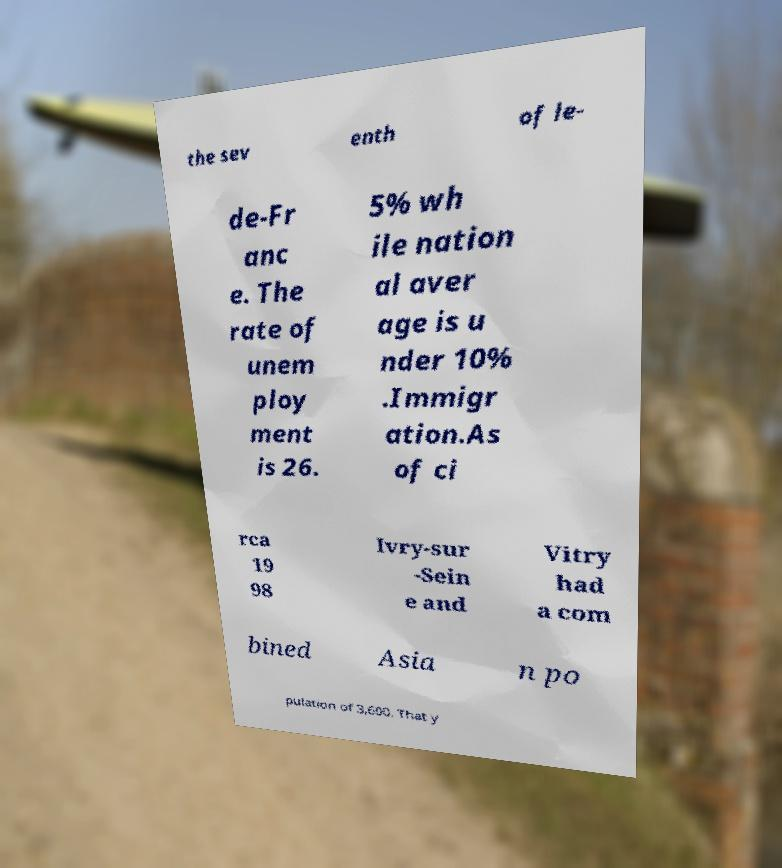Please identify and transcribe the text found in this image. the sev enth of le- de-Fr anc e. The rate of unem ploy ment is 26. 5% wh ile nation al aver age is u nder 10% .Immigr ation.As of ci rca 19 98 Ivry-sur -Sein e and Vitry had a com bined Asia n po pulation of 3,600. That y 